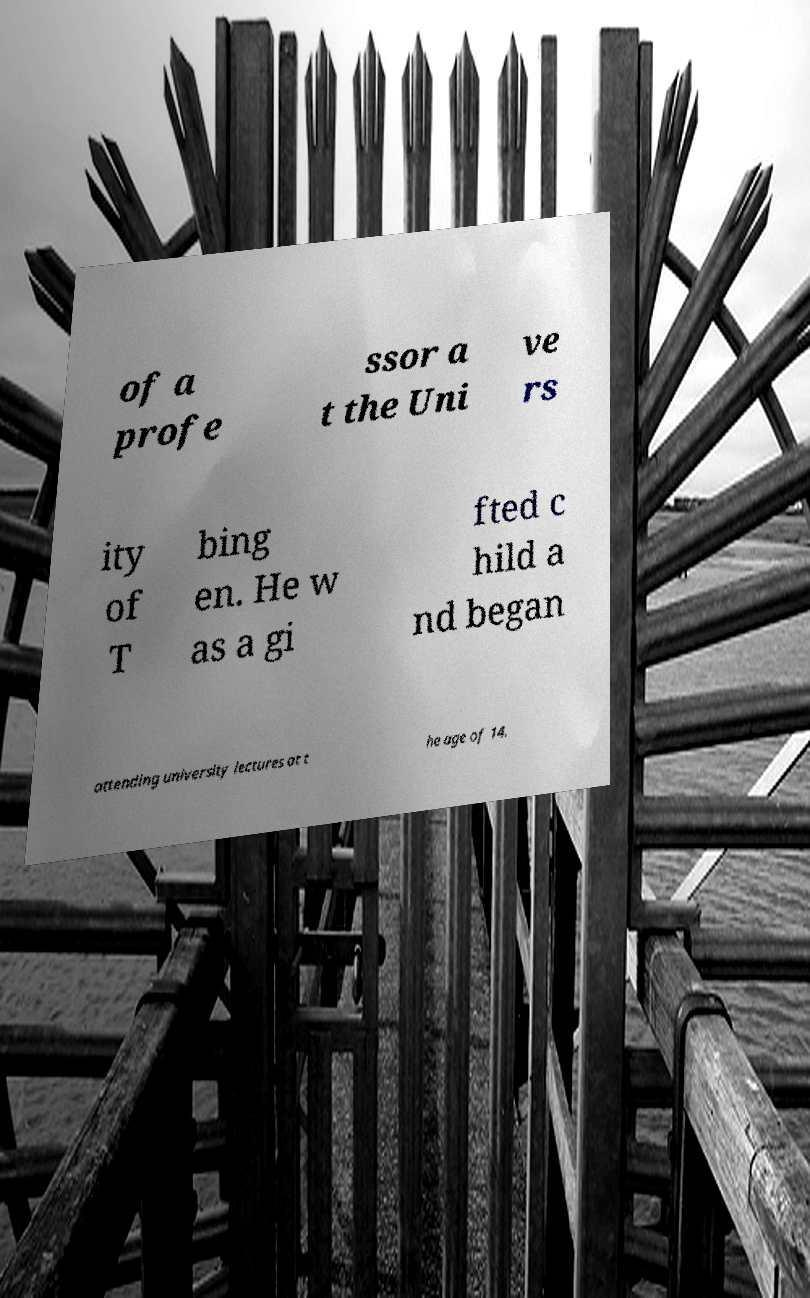Please identify and transcribe the text found in this image. of a profe ssor a t the Uni ve rs ity of T bing en. He w as a gi fted c hild a nd began attending university lectures at t he age of 14. 